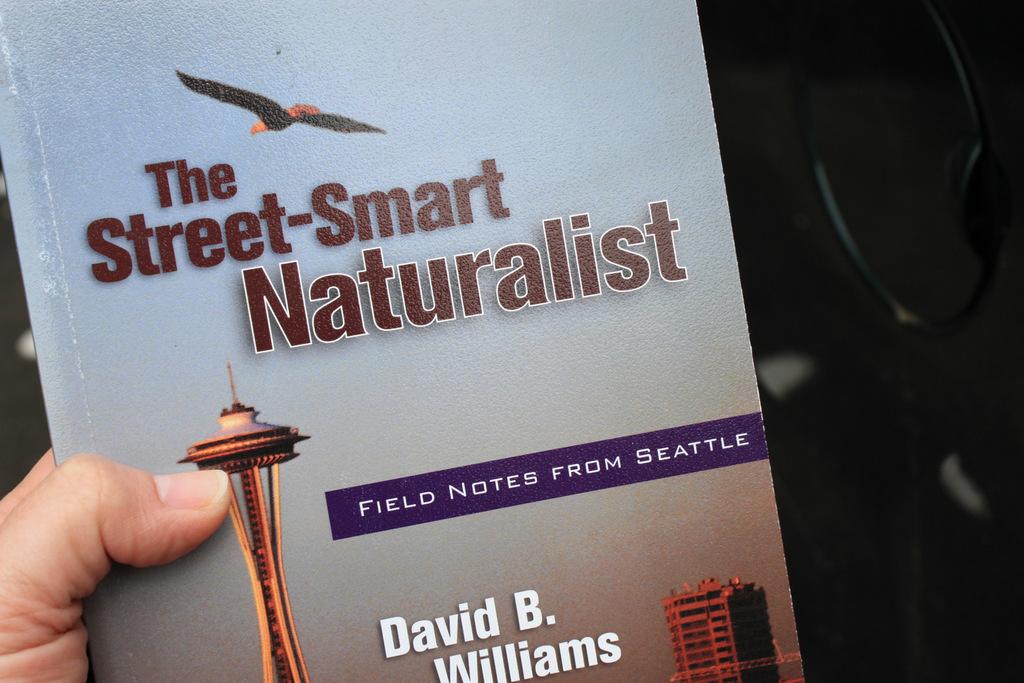What is the title of the book?
Provide a succinct answer. The street-smart naturalist. 